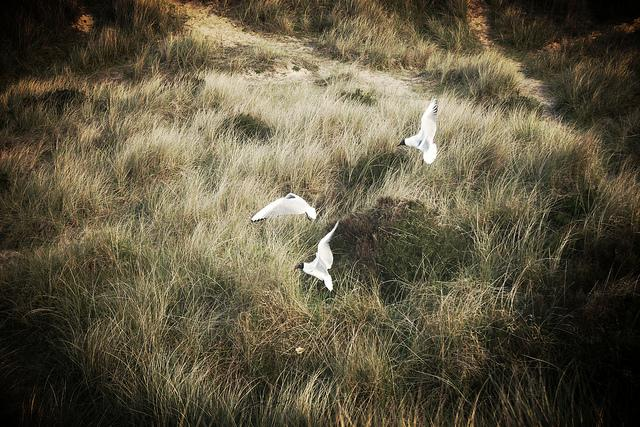What color are the beaks of these birds? Please explain your reasoning. black. The birds' beaks are black. 